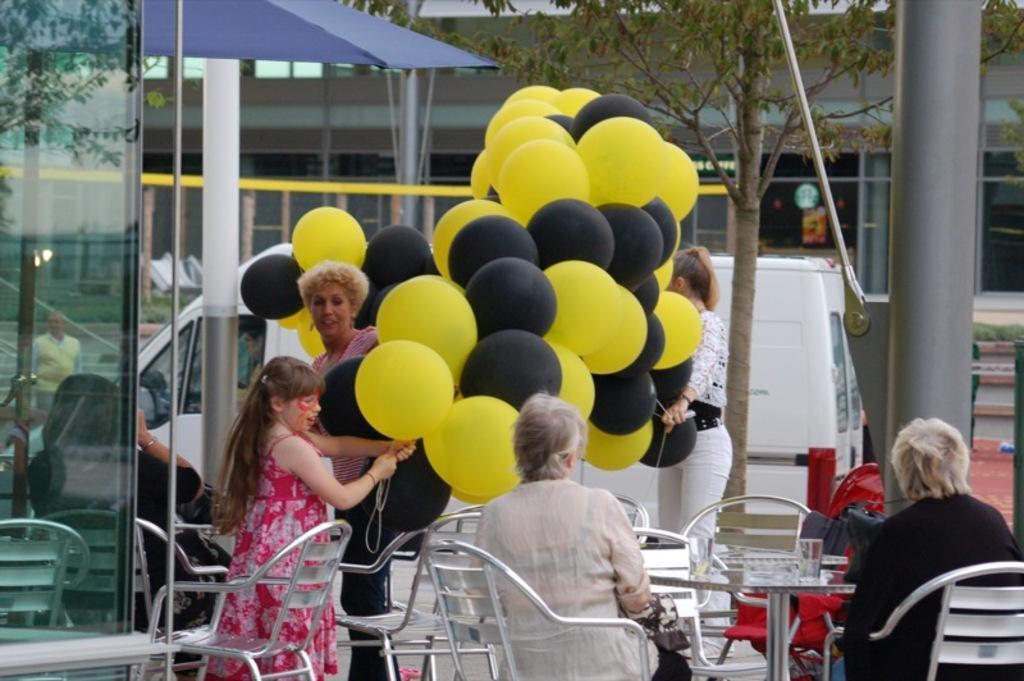Could you give a brief overview of what you see in this image? In this image there are two persons sitting on chairs, in the middle there is a table on that table there are glasses, beside the chairs a girl is standing and holding balloons in her hands, beside the girl a woman standing, in the background there are buildings, tree. 